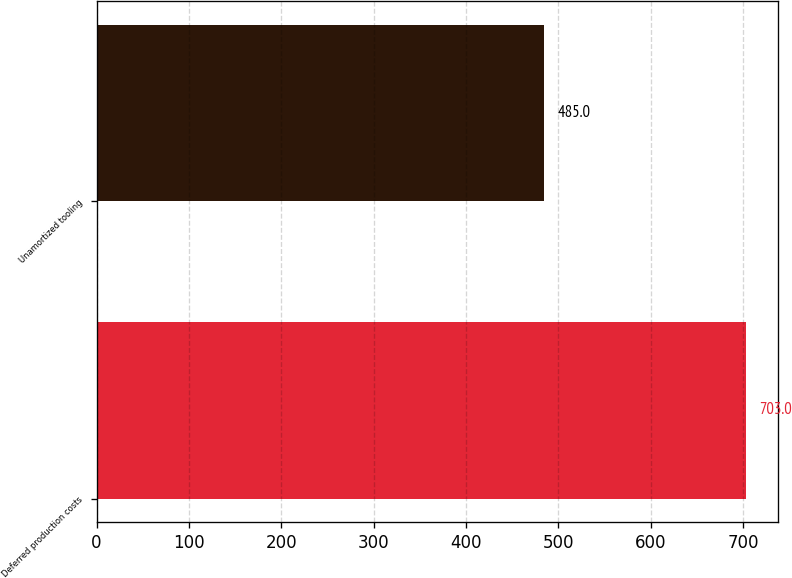Convert chart to OTSL. <chart><loc_0><loc_0><loc_500><loc_500><bar_chart><fcel>Deferred production costs<fcel>Unamortized tooling<nl><fcel>703<fcel>485<nl></chart> 